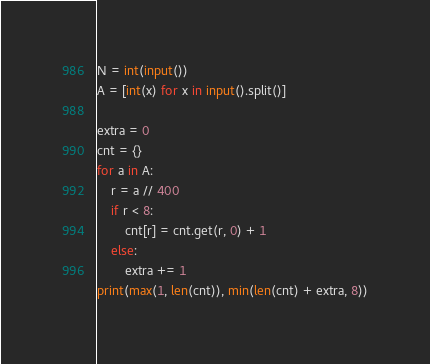<code> <loc_0><loc_0><loc_500><loc_500><_Python_>N = int(input())
A = [int(x) for x in input().split()]

extra = 0
cnt = {}
for a in A:
    r = a // 400
    if r < 8:
        cnt[r] = cnt.get(r, 0) + 1
    else:
        extra += 1
print(max(1, len(cnt)), min(len(cnt) + extra, 8))</code> 